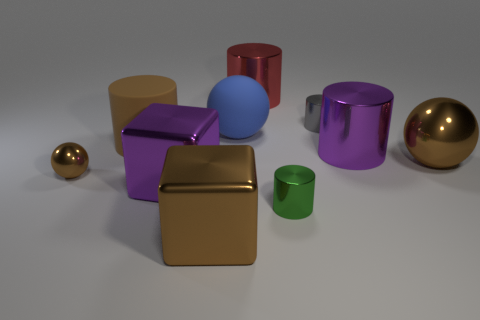Subtract all cyan cylinders. Subtract all gray blocks. How many cylinders are left? 5 Subtract all spheres. How many objects are left? 7 Add 6 big purple metal objects. How many big purple metal objects exist? 8 Subtract 1 red cylinders. How many objects are left? 9 Subtract all small gray metallic objects. Subtract all purple shiny cylinders. How many objects are left? 8 Add 8 red metallic cylinders. How many red metallic cylinders are left? 9 